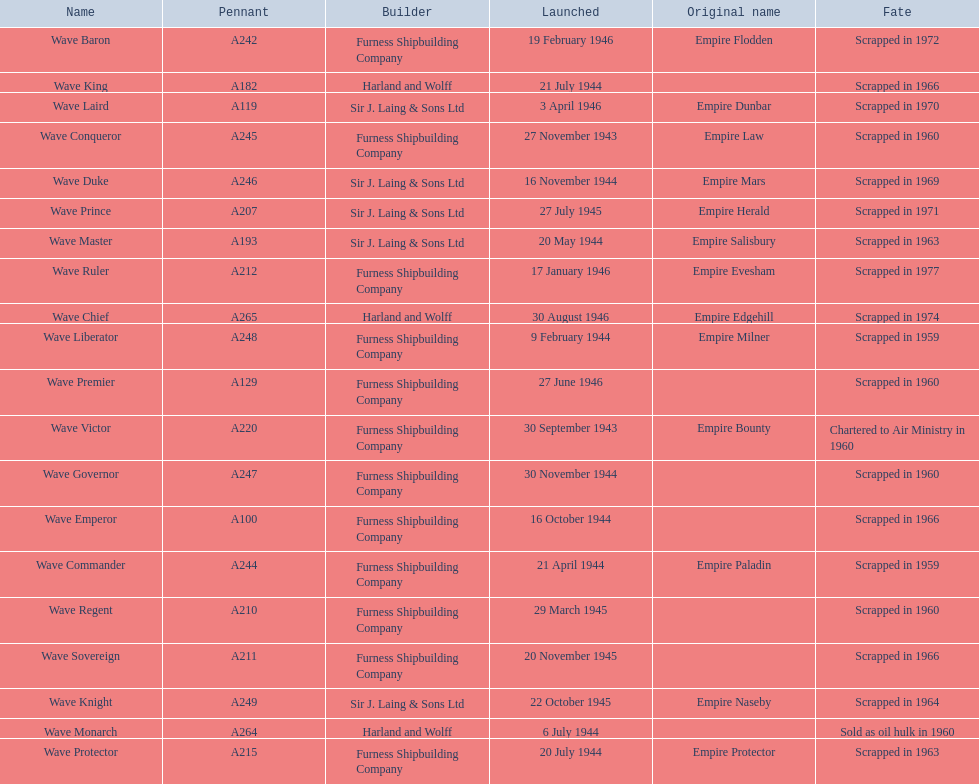What date was the wave victor launched? 30 September 1943. What other oiler was launched that same year? Wave Conqueror. 